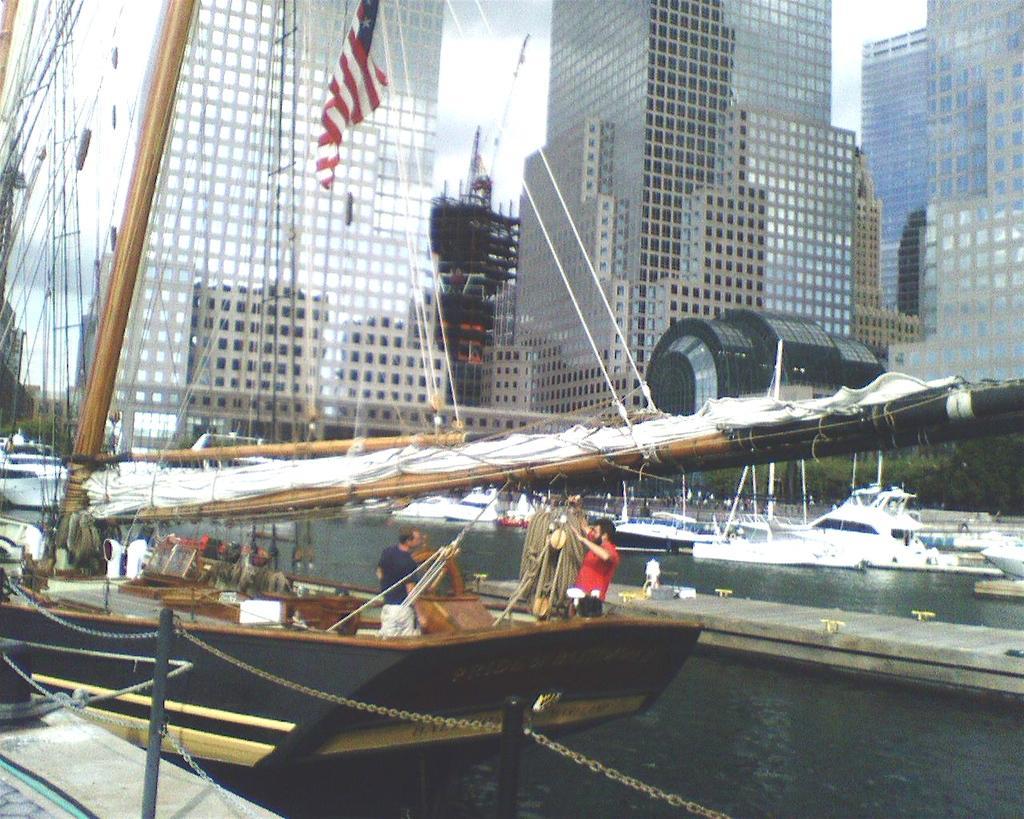Please provide a concise description of this image. In this image there is water at the bottom. In the water there are so many boats. In the background there are tall buildings with the glasses. In the middle there is a flag which is tied to the rope. At the bottom on the left side there is a fence. 